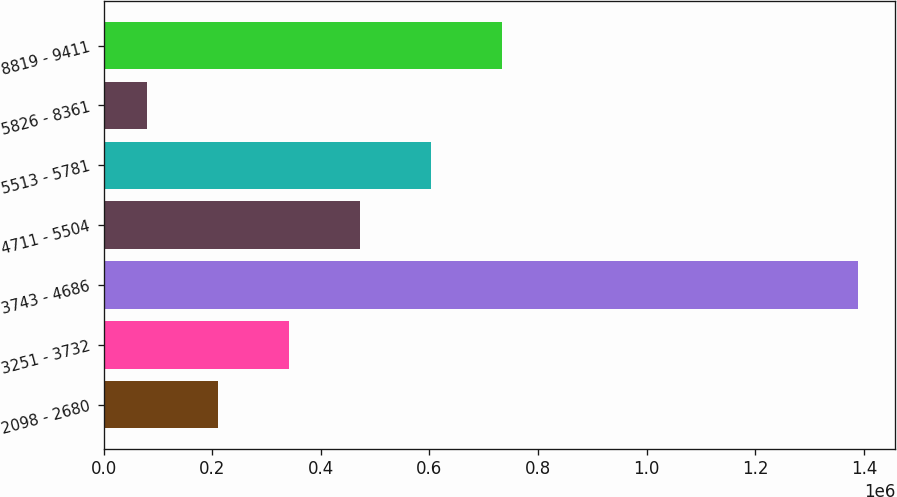<chart> <loc_0><loc_0><loc_500><loc_500><bar_chart><fcel>2098 - 2680<fcel>3251 - 3732<fcel>3743 - 4686<fcel>4711 - 5504<fcel>5513 - 5781<fcel>5826 - 8361<fcel>8819 - 9411<nl><fcel>210266<fcel>341157<fcel>1.38829e+06<fcel>472049<fcel>602940<fcel>79375<fcel>733831<nl></chart> 